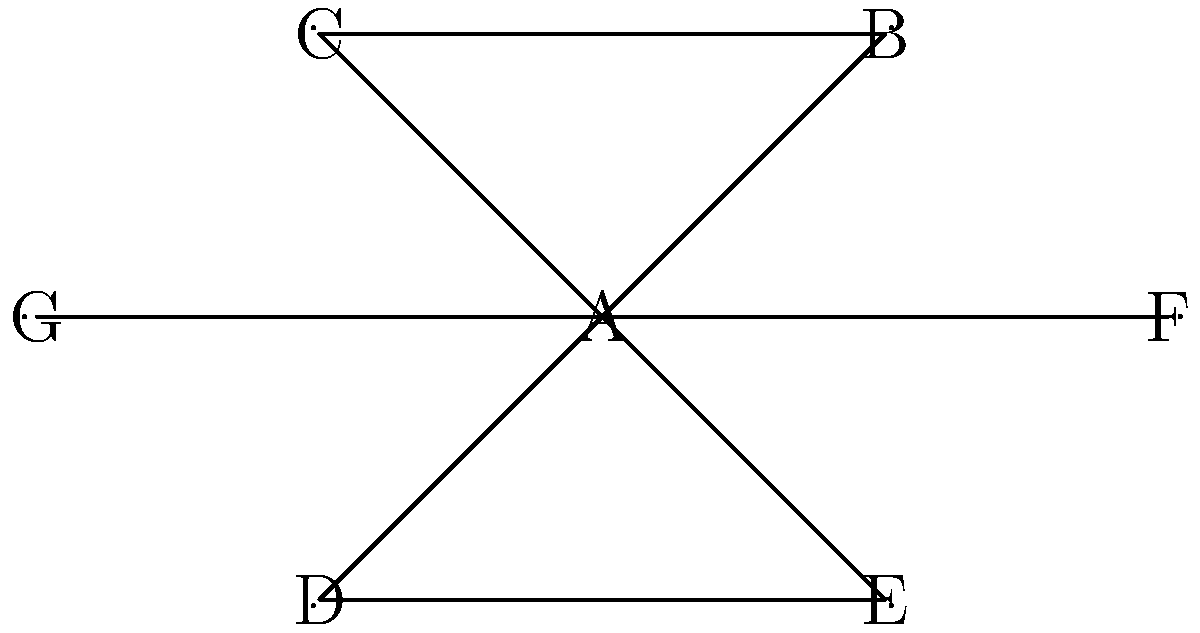In a network of child trauma specialists, represented by the graph above, each node represents a specialist, and edges represent direct collaboration. Which specialist has the highest degree centrality, and what is their degree centrality value? To solve this problem, we need to follow these steps:

1. Understand degree centrality:
   Degree centrality is a measure of the number of direct connections a node has in a network.

2. Count the connections for each node:
   A: 6 connections (to B, C, D, E, F, G)
   B: 2 connections (to A, C)
   C: 2 connections (to A, B)
   D: 2 connections (to A, E)
   E: 2 connections (to A, D)
   F: 2 connections (to A, G)
   G: 2 connections (to A, F)

3. Identify the highest degree centrality:
   Node A has the highest number of connections with 6.

4. Calculate the degree centrality value:
   In a network with $n$ nodes, the degree centrality is normalized by dividing the degree by $(n-1)$.
   In this case, $n = 7$.
   Degree centrality for A = $\frac{6}{7-1} = \frac{6}{6} = 1$

Therefore, specialist A has the highest degree centrality with a value of 1.
Answer: Specialist A, 1 